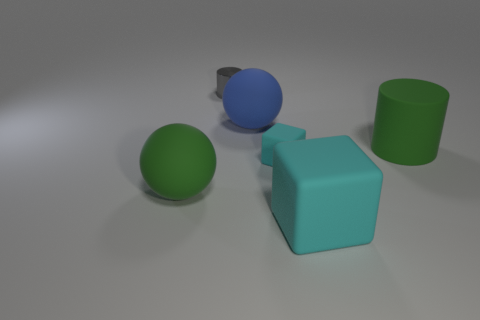Are there any other things that have the same size as the gray shiny cylinder?
Your answer should be very brief. Yes. There is a cylinder that is made of the same material as the small cyan object; what color is it?
Your answer should be compact. Green. Are the big green sphere and the cyan cube that is left of the large matte cube made of the same material?
Your response must be concise. Yes. There is a large matte object that is to the right of the tiny cylinder and on the left side of the big cyan block; what color is it?
Your answer should be compact. Blue. How many spheres are yellow matte things or green objects?
Offer a terse response. 1. Is the shape of the gray shiny object the same as the large rubber object on the left side of the tiny gray thing?
Ensure brevity in your answer.  No. There is a thing that is both right of the gray metal cylinder and behind the large green rubber cylinder; how big is it?
Provide a succinct answer. Large. What is the shape of the blue rubber thing?
Your answer should be compact. Sphere. There is a small gray thing that is behind the tiny rubber object; is there a big rubber ball that is behind it?
Keep it short and to the point. No. What number of cyan things are to the right of the rubber ball in front of the green matte cylinder?
Ensure brevity in your answer.  2. 